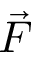<formula> <loc_0><loc_0><loc_500><loc_500>\vec { F }</formula> 